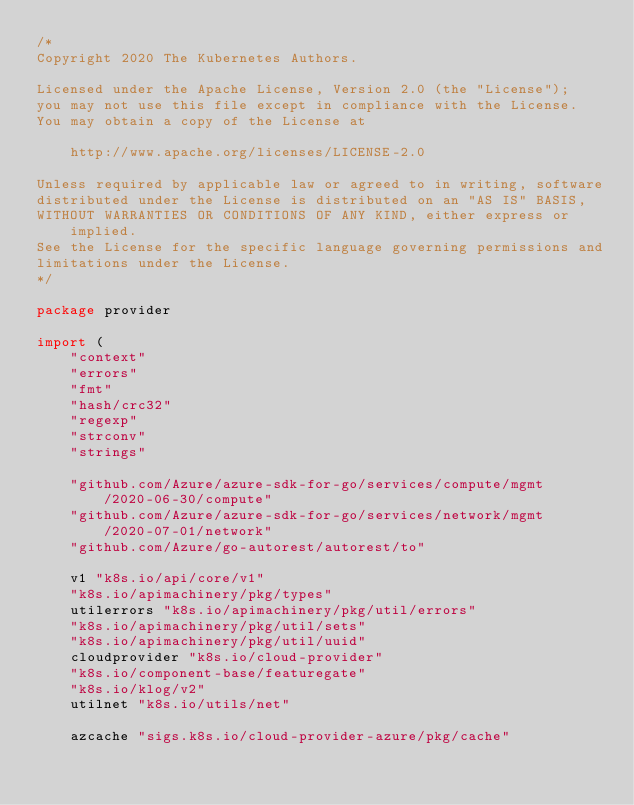Convert code to text. <code><loc_0><loc_0><loc_500><loc_500><_Go_>/*
Copyright 2020 The Kubernetes Authors.

Licensed under the Apache License, Version 2.0 (the "License");
you may not use this file except in compliance with the License.
You may obtain a copy of the License at

    http://www.apache.org/licenses/LICENSE-2.0

Unless required by applicable law or agreed to in writing, software
distributed under the License is distributed on an "AS IS" BASIS,
WITHOUT WARRANTIES OR CONDITIONS OF ANY KIND, either express or implied.
See the License for the specific language governing permissions and
limitations under the License.
*/

package provider

import (
	"context"
	"errors"
	"fmt"
	"hash/crc32"
	"regexp"
	"strconv"
	"strings"

	"github.com/Azure/azure-sdk-for-go/services/compute/mgmt/2020-06-30/compute"
	"github.com/Azure/azure-sdk-for-go/services/network/mgmt/2020-07-01/network"
	"github.com/Azure/go-autorest/autorest/to"

	v1 "k8s.io/api/core/v1"
	"k8s.io/apimachinery/pkg/types"
	utilerrors "k8s.io/apimachinery/pkg/util/errors"
	"k8s.io/apimachinery/pkg/util/sets"
	"k8s.io/apimachinery/pkg/util/uuid"
	cloudprovider "k8s.io/cloud-provider"
	"k8s.io/component-base/featuregate"
	"k8s.io/klog/v2"
	utilnet "k8s.io/utils/net"

	azcache "sigs.k8s.io/cloud-provider-azure/pkg/cache"</code> 